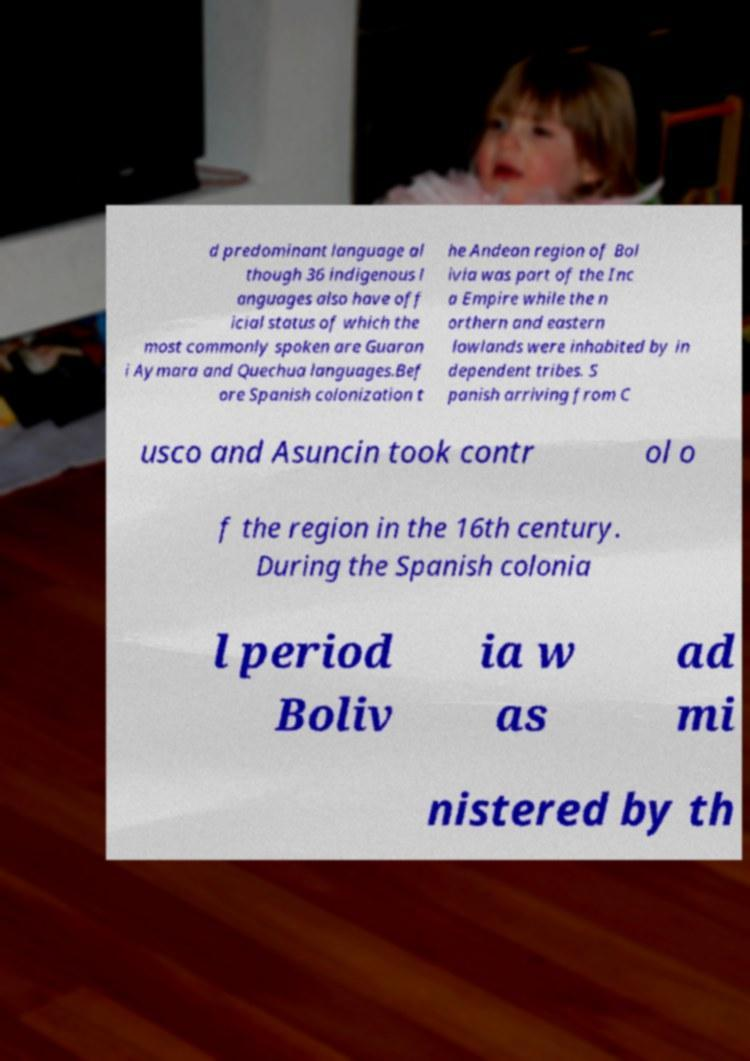Please read and relay the text visible in this image. What does it say? d predominant language al though 36 indigenous l anguages also have off icial status of which the most commonly spoken are Guaran i Aymara and Quechua languages.Bef ore Spanish colonization t he Andean region of Bol ivia was part of the Inc a Empire while the n orthern and eastern lowlands were inhabited by in dependent tribes. S panish arriving from C usco and Asuncin took contr ol o f the region in the 16th century. During the Spanish colonia l period Boliv ia w as ad mi nistered by th 